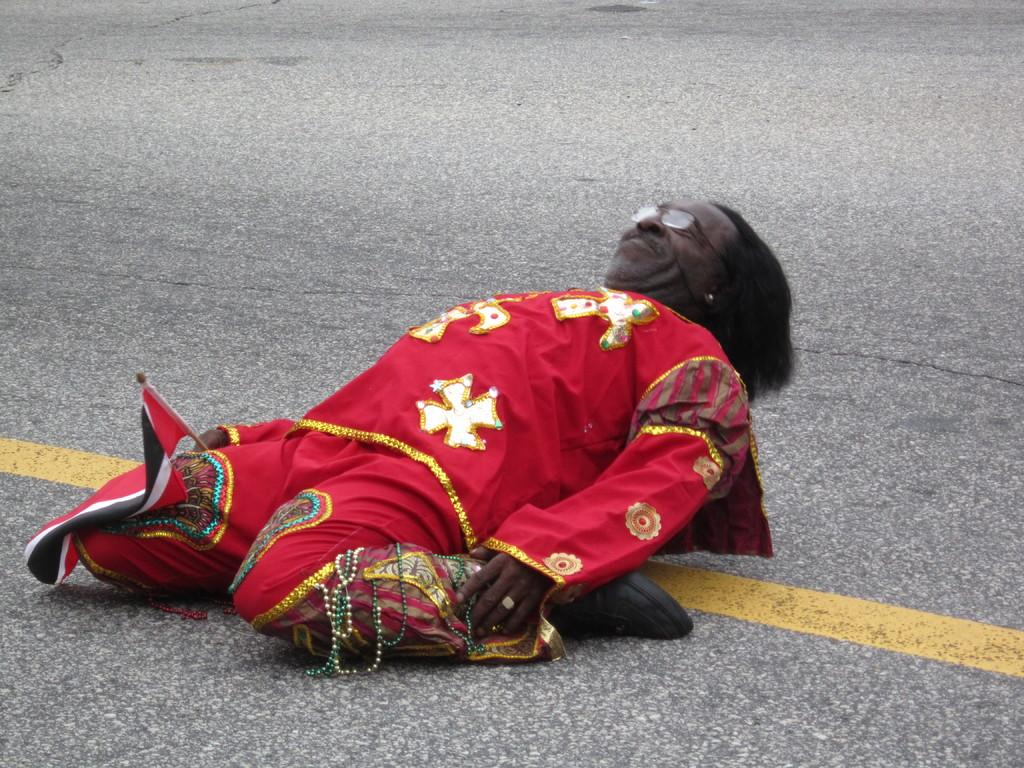What is the main subject of the image? There is a person in the image. What is the person wearing? The person is wearing a red dress. What position is the person in? The person is sitting on their legs on the road. What is the person doing in the image? The person is lying down. What type of bucket can be seen next to the person in the image? There is no bucket present in the image. What kind of earth is visible around the person in the image? The image does not show any earth or soil around the person. 